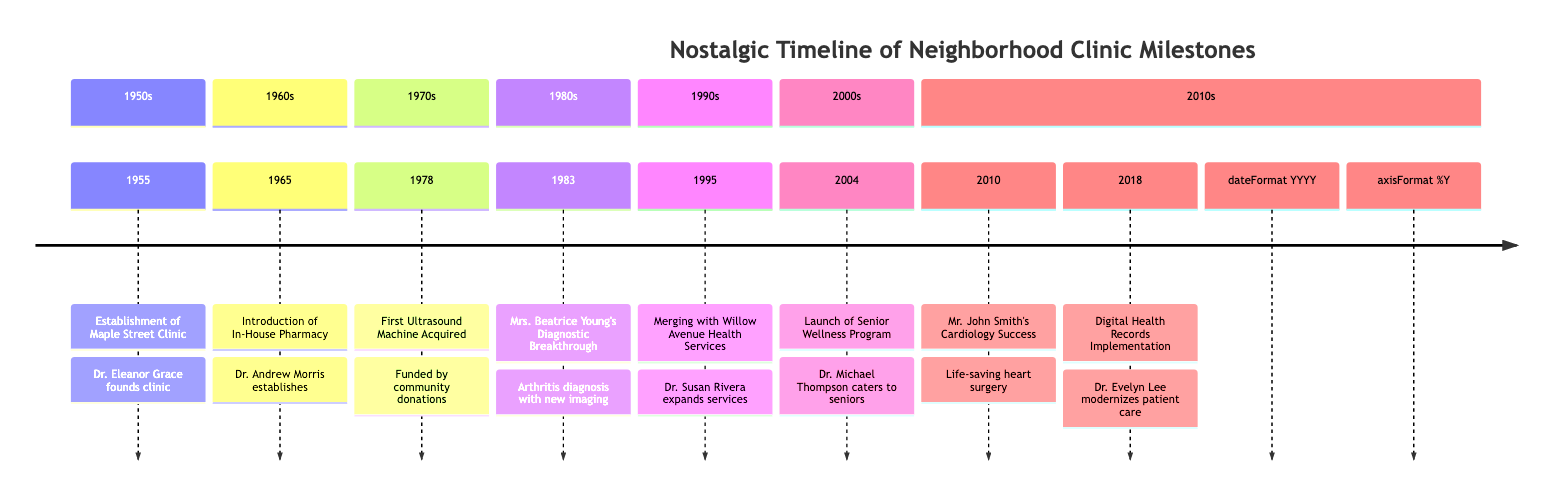What year was the Maple Street Clinic established? The diagram indicates that the Maple Street Clinic was established in 1955, which is clearly labeled as the first milestone on the timeline.
Answer: 1955 Who founded the clinic? According to the timeline, the clinic was founded by Dr. Eleanor Grace, as stated in the description for the establishment event.
Answer: Dr. Eleanor Grace What significant event occurred in 1965 at the clinic? In 1965, the timeline highlights the introduction of an In-House Pharmacy, which was a significant milestone for the clinic.
Answer: Introduction of In-House Pharmacy What community contribution helped acquire the first ultrasound machine? The diagram states that the first ultrasound machine acquired in 1978 was funded by community donations, emphasizing the importance of local support.
Answer: Community donations Which patient story is featured in 2010? The patient story illustrated in 2010 discusses Mr. John Smith's cardiology success, highlighting a notable case in that year.
Answer: Mr. John Smith's Cardiology Success How many events are listed in the 1980s section of the timeline? The 1980s section contains only one event, which is Mrs. Beatrice Young's Diagnostic Breakthrough in 1983.
Answer: 1 What was launched in 2004? The timeline mentions that the Senior Wellness Program was launched in 2004, initiated by Dr. Michael Thompson to address the needs of aging residents.
Answer: Senior Wellness Program What was a significant change implemented in 2018? The diagram indicates that Digital Health Records were implemented in 2018, marking a modernization step for the clinic under Dr. Evelyn Lee.
Answer: Digital Health Records Implementation What connects the merger in 1995 to the establishment in 1955? The timeline shows a direct relationship where the merger in 1995, which expanded services, connects to the earlier establishment of the clinic in 1955, indicating the clinic's growth over time.
Answer: Expansion of services 